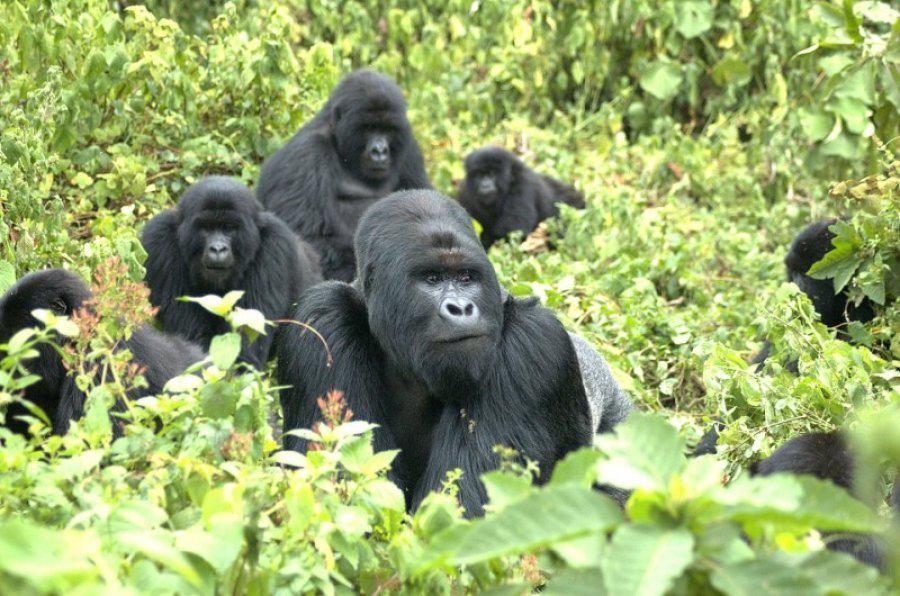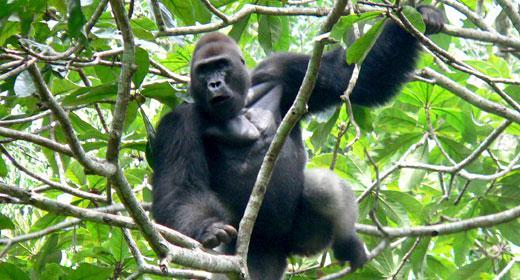The first image is the image on the left, the second image is the image on the right. For the images displayed, is the sentence "In total, the images depict at least four black-haired apes." factually correct? Answer yes or no. Yes. 